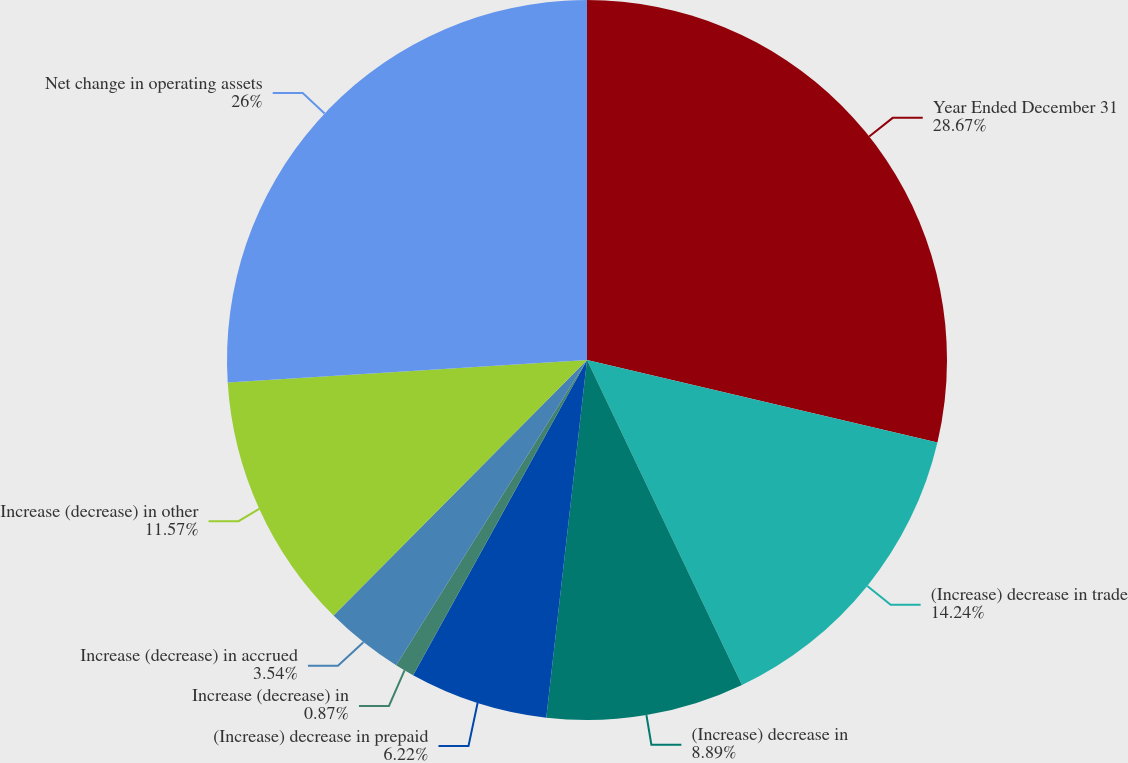Convert chart to OTSL. <chart><loc_0><loc_0><loc_500><loc_500><pie_chart><fcel>Year Ended December 31<fcel>(Increase) decrease in trade<fcel>(Increase) decrease in<fcel>(Increase) decrease in prepaid<fcel>Increase (decrease) in<fcel>Increase (decrease) in accrued<fcel>Increase (decrease) in other<fcel>Net change in operating assets<nl><fcel>28.68%<fcel>14.24%<fcel>8.89%<fcel>6.22%<fcel>0.87%<fcel>3.54%<fcel>11.57%<fcel>26.0%<nl></chart> 